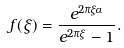<formula> <loc_0><loc_0><loc_500><loc_500>f ( \xi ) = \frac { e ^ { 2 \pi \xi \alpha } } { e ^ { 2 \pi \xi } - 1 } .</formula> 